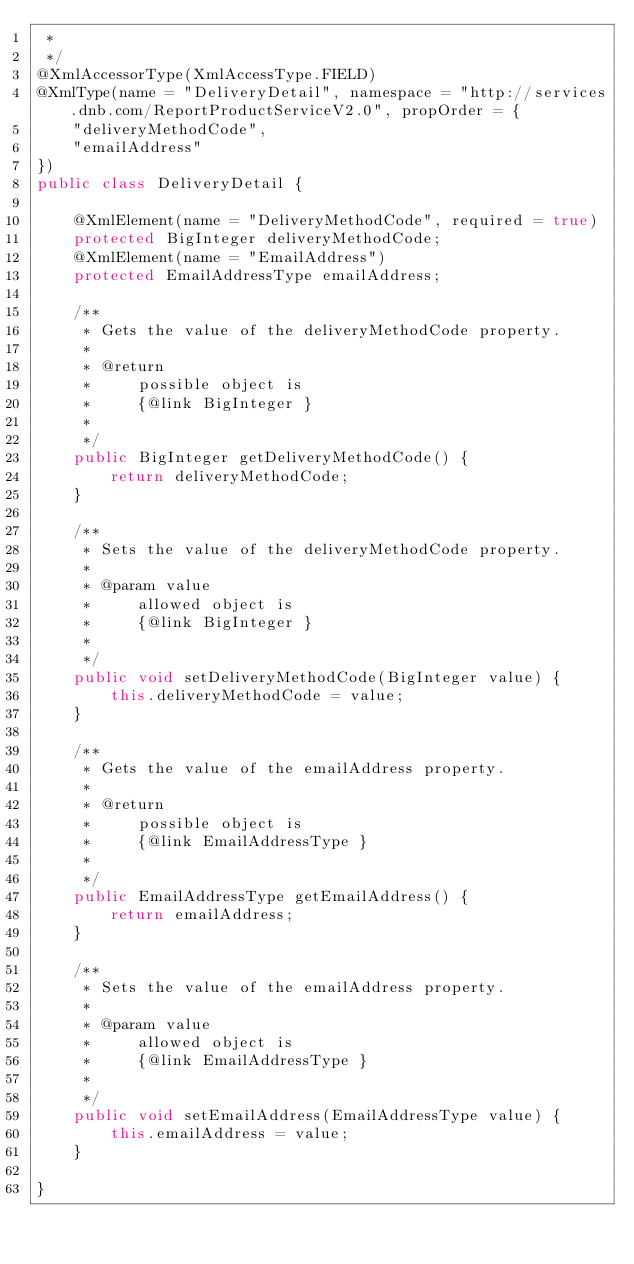Convert code to text. <code><loc_0><loc_0><loc_500><loc_500><_Java_> * 
 */
@XmlAccessorType(XmlAccessType.FIELD)
@XmlType(name = "DeliveryDetail", namespace = "http://services.dnb.com/ReportProductServiceV2.0", propOrder = {
    "deliveryMethodCode",
    "emailAddress"
})
public class DeliveryDetail {

    @XmlElement(name = "DeliveryMethodCode", required = true)
    protected BigInteger deliveryMethodCode;
    @XmlElement(name = "EmailAddress")
    protected EmailAddressType emailAddress;

    /**
     * Gets the value of the deliveryMethodCode property.
     * 
     * @return
     *     possible object is
     *     {@link BigInteger }
     *     
     */
    public BigInteger getDeliveryMethodCode() {
        return deliveryMethodCode;
    }

    /**
     * Sets the value of the deliveryMethodCode property.
     * 
     * @param value
     *     allowed object is
     *     {@link BigInteger }
     *     
     */
    public void setDeliveryMethodCode(BigInteger value) {
        this.deliveryMethodCode = value;
    }

    /**
     * Gets the value of the emailAddress property.
     * 
     * @return
     *     possible object is
     *     {@link EmailAddressType }
     *     
     */
    public EmailAddressType getEmailAddress() {
        return emailAddress;
    }

    /**
     * Sets the value of the emailAddress property.
     * 
     * @param value
     *     allowed object is
     *     {@link EmailAddressType }
     *     
     */
    public void setEmailAddress(EmailAddressType value) {
        this.emailAddress = value;
    }

}
</code> 